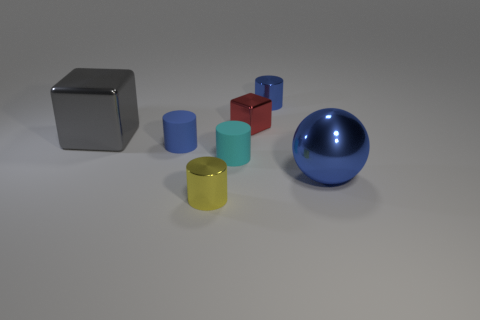Subtract all brown cylinders. Subtract all green spheres. How many cylinders are left? 4 Add 3 small brown matte objects. How many objects exist? 10 Subtract all cylinders. How many objects are left? 3 Add 1 tiny purple shiny objects. How many tiny purple shiny objects exist? 1 Subtract 0 brown cylinders. How many objects are left? 7 Subtract all small gray rubber cylinders. Subtract all tiny blue shiny cylinders. How many objects are left? 6 Add 3 metal balls. How many metal balls are left? 4 